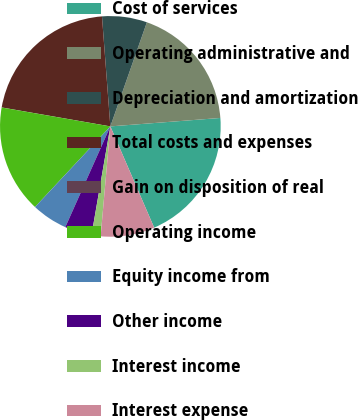Convert chart to OTSL. <chart><loc_0><loc_0><loc_500><loc_500><pie_chart><fcel>Cost of services<fcel>Operating administrative and<fcel>Depreciation and amortization<fcel>Total costs and expenses<fcel>Gain on disposition of real<fcel>Operating income<fcel>Equity income from<fcel>Other income<fcel>Interest income<fcel>Interest expense<nl><fcel>19.72%<fcel>18.41%<fcel>6.58%<fcel>21.04%<fcel>0.01%<fcel>15.78%<fcel>5.27%<fcel>3.96%<fcel>1.33%<fcel>7.9%<nl></chart> 